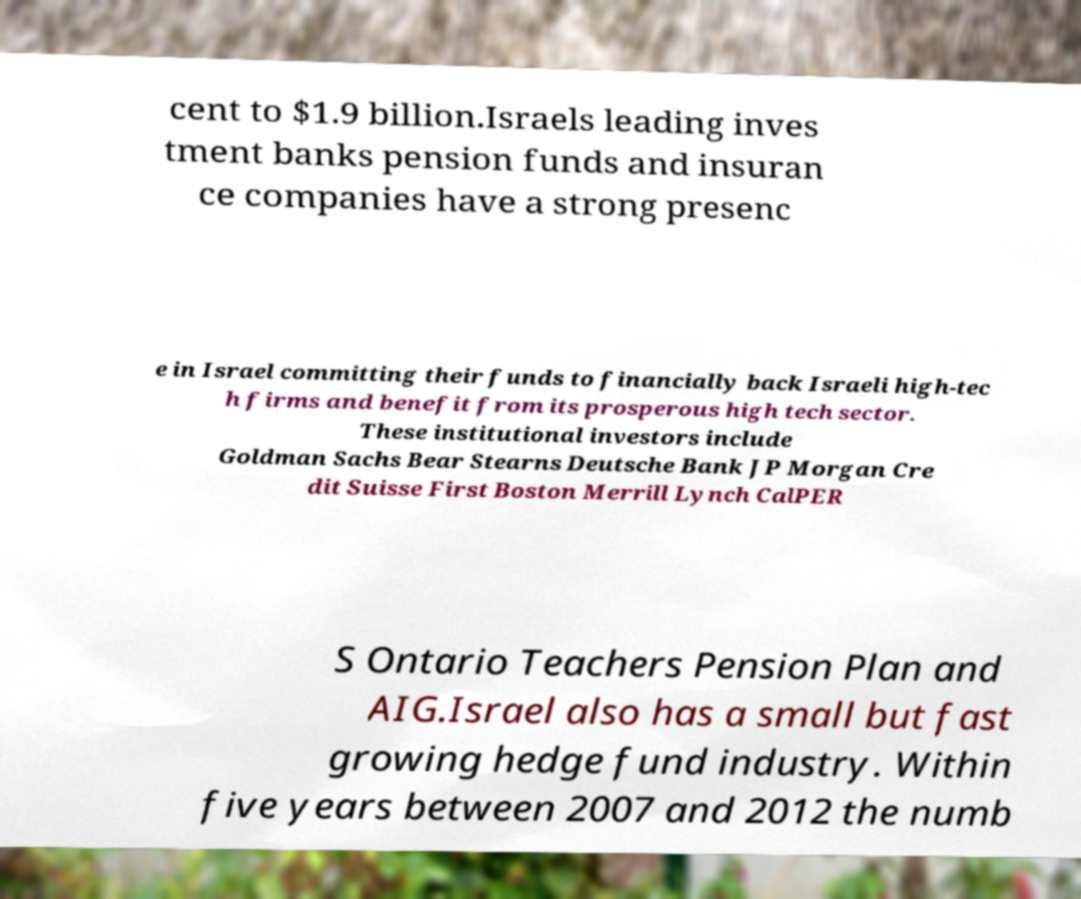Can you accurately transcribe the text from the provided image for me? cent to $1.9 billion.Israels leading inves tment banks pension funds and insuran ce companies have a strong presenc e in Israel committing their funds to financially back Israeli high-tec h firms and benefit from its prosperous high tech sector. These institutional investors include Goldman Sachs Bear Stearns Deutsche Bank JP Morgan Cre dit Suisse First Boston Merrill Lynch CalPER S Ontario Teachers Pension Plan and AIG.Israel also has a small but fast growing hedge fund industry. Within five years between 2007 and 2012 the numb 